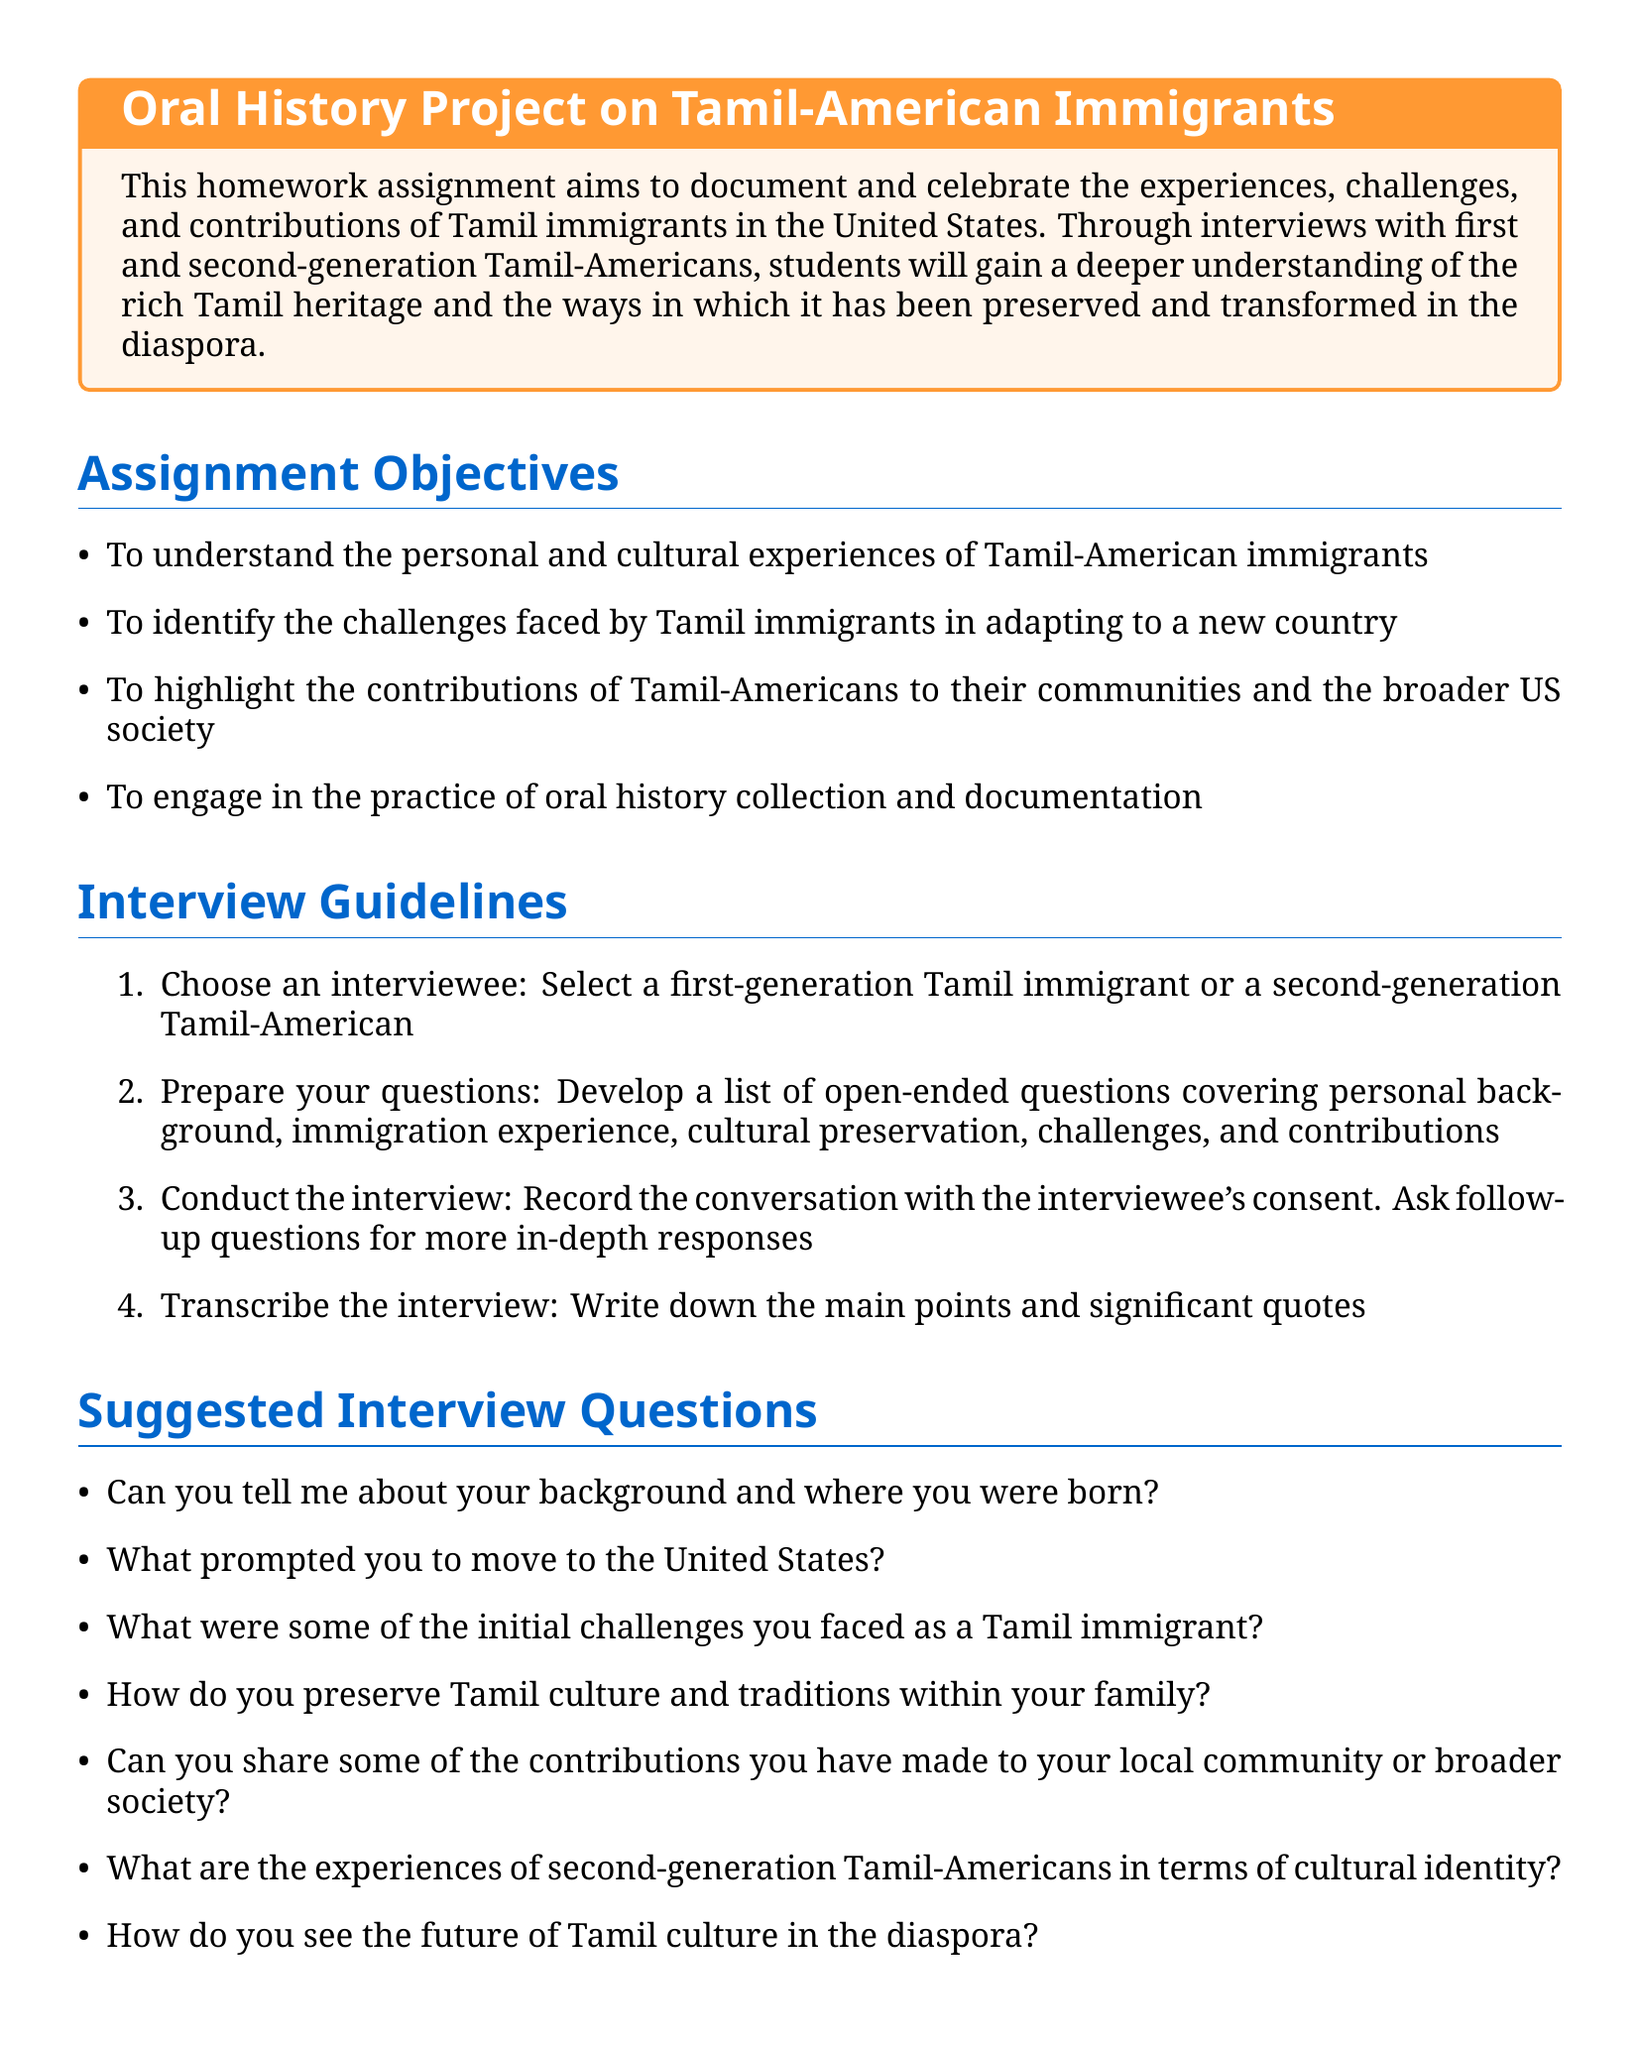what is the title of the homework assignment? The title is located at the beginning of the document within the tcolorbox.
Answer: Oral History Project on Tamil-American Immigrants how many objectives are listed in the assignment? The number of objectives is counted under the Assignment Objectives section.
Answer: four what is the color used for the title section? The color reference for the title section is stated in the title format section.
Answer: tamilblue who is the author of 'The United States of India'? The book's author is mentioned in the Resources section of the document.
Answer: Gaiutra Bahadur what should be included in the personal reflection? This information is found in the Documentation and Submission section regarding what students need to write.
Answer: what you learned and how it impacted your understanding of Tamil-American experiences what step involves recording the conversation? The document outlines the process of conducting the interview.
Answer: Conduct the interview what is the suggested method for summarizing the interview? This is detailed in the Documentation and Submission section of the document.
Answer: Create a one-page summary what are the initial challenges faced by Tamil immigrants referred to in the suggested interview questions? This information is listed under the suggested interview questions that students can inquire about.
Answer: initial challenges 